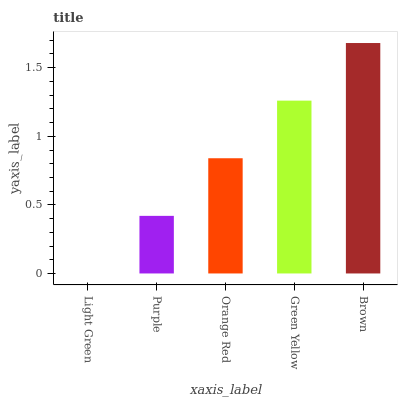Is Light Green the minimum?
Answer yes or no. Yes. Is Brown the maximum?
Answer yes or no. Yes. Is Purple the minimum?
Answer yes or no. No. Is Purple the maximum?
Answer yes or no. No. Is Purple greater than Light Green?
Answer yes or no. Yes. Is Light Green less than Purple?
Answer yes or no. Yes. Is Light Green greater than Purple?
Answer yes or no. No. Is Purple less than Light Green?
Answer yes or no. No. Is Orange Red the high median?
Answer yes or no. Yes. Is Orange Red the low median?
Answer yes or no. Yes. Is Green Yellow the high median?
Answer yes or no. No. Is Green Yellow the low median?
Answer yes or no. No. 